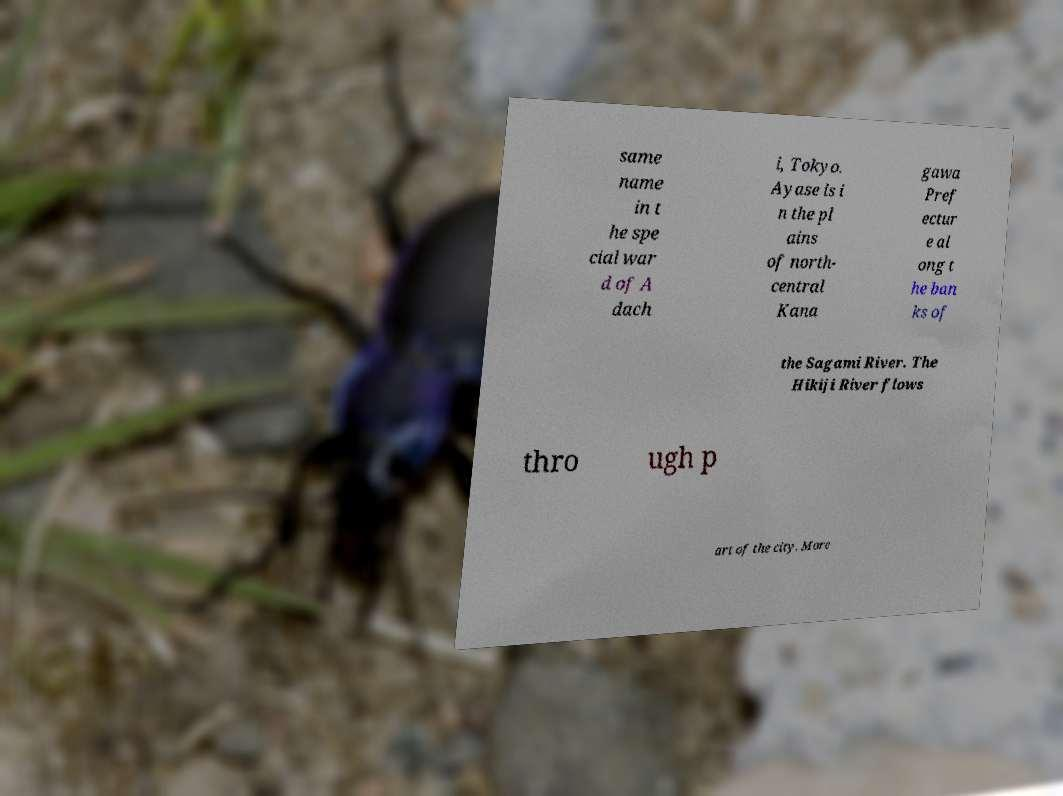What messages or text are displayed in this image? I need them in a readable, typed format. same name in t he spe cial war d of A dach i, Tokyo. Ayase is i n the pl ains of north- central Kana gawa Pref ectur e al ong t he ban ks of the Sagami River. The Hikiji River flows thro ugh p art of the city. More 